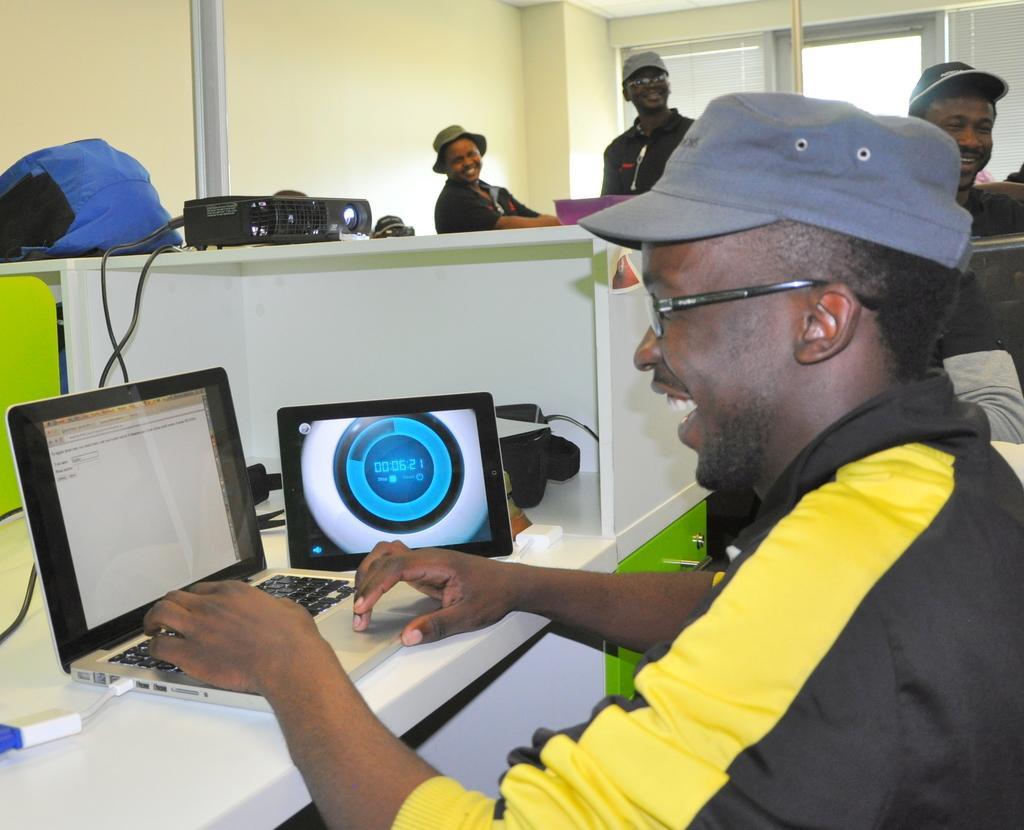Can you describe this image briefly? In this image we can see group of persons, there a man is sitting, and smiling, in front there is a laptop on the table, there are persons standing, there is a glass window, there is a wall. 